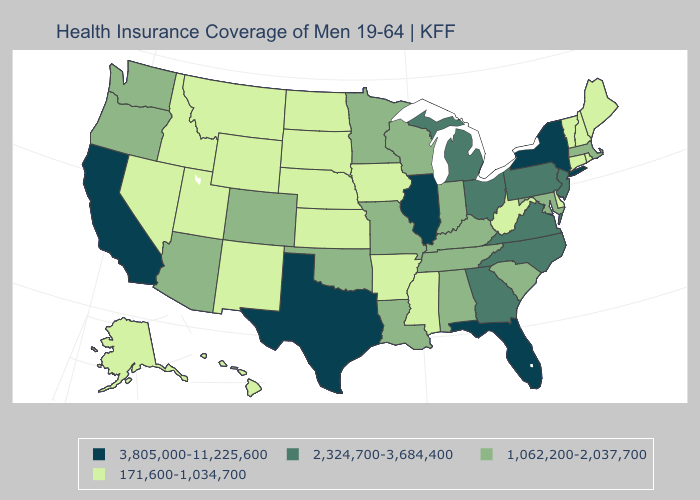Among the states that border Colorado , does Nebraska have the lowest value?
Be succinct. Yes. Which states have the highest value in the USA?
Give a very brief answer. California, Florida, Illinois, New York, Texas. Does New York have the highest value in the Northeast?
Be succinct. Yes. Which states hav the highest value in the South?
Answer briefly. Florida, Texas. Does Nevada have the lowest value in the West?
Be succinct. Yes. Does California have the highest value in the USA?
Give a very brief answer. Yes. Name the states that have a value in the range 1,062,200-2,037,700?
Short answer required. Alabama, Arizona, Colorado, Indiana, Kentucky, Louisiana, Maryland, Massachusetts, Minnesota, Missouri, Oklahoma, Oregon, South Carolina, Tennessee, Washington, Wisconsin. Name the states that have a value in the range 1,062,200-2,037,700?
Quick response, please. Alabama, Arizona, Colorado, Indiana, Kentucky, Louisiana, Maryland, Massachusetts, Minnesota, Missouri, Oklahoma, Oregon, South Carolina, Tennessee, Washington, Wisconsin. Name the states that have a value in the range 171,600-1,034,700?
Concise answer only. Alaska, Arkansas, Connecticut, Delaware, Hawaii, Idaho, Iowa, Kansas, Maine, Mississippi, Montana, Nebraska, Nevada, New Hampshire, New Mexico, North Dakota, Rhode Island, South Dakota, Utah, Vermont, West Virginia, Wyoming. What is the value of Montana?
Give a very brief answer. 171,600-1,034,700. Does Connecticut have the highest value in the USA?
Short answer required. No. Does the map have missing data?
Answer briefly. No. Which states have the lowest value in the MidWest?
Be succinct. Iowa, Kansas, Nebraska, North Dakota, South Dakota. Name the states that have a value in the range 2,324,700-3,684,400?
Keep it brief. Georgia, Michigan, New Jersey, North Carolina, Ohio, Pennsylvania, Virginia. Does Iowa have a higher value than Minnesota?
Quick response, please. No. 